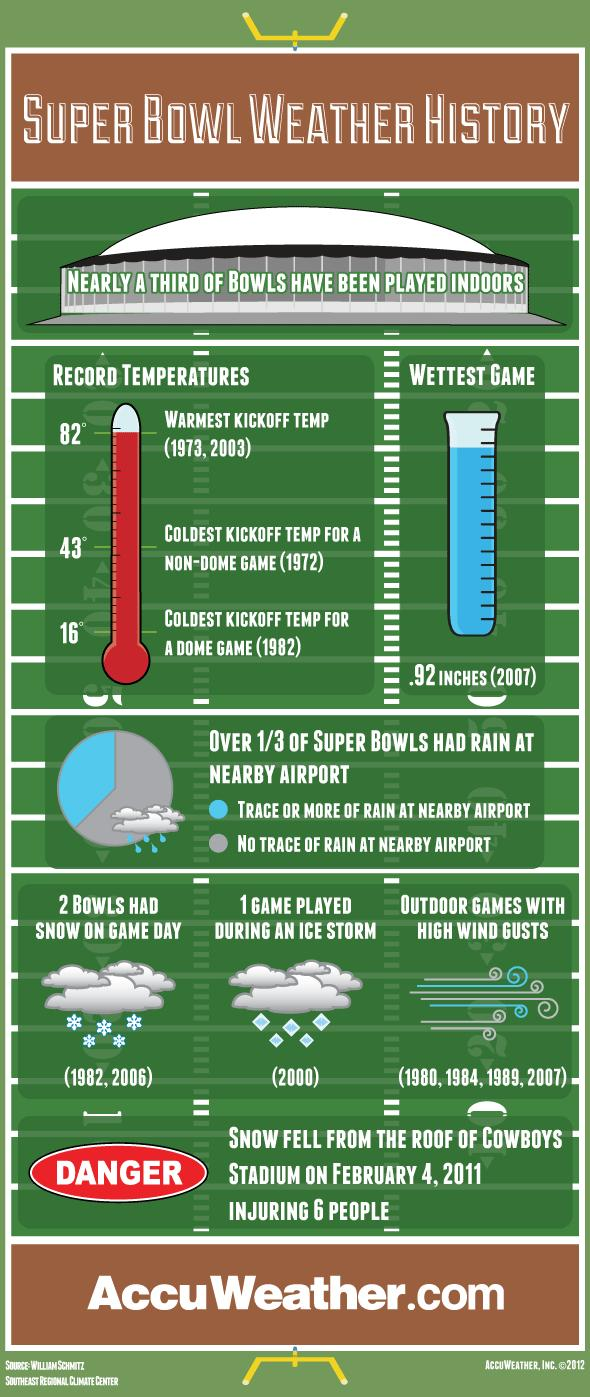Indicate a few pertinent items in this graphic. The Super Bowl game was played during an ice storm in the year 2000. 